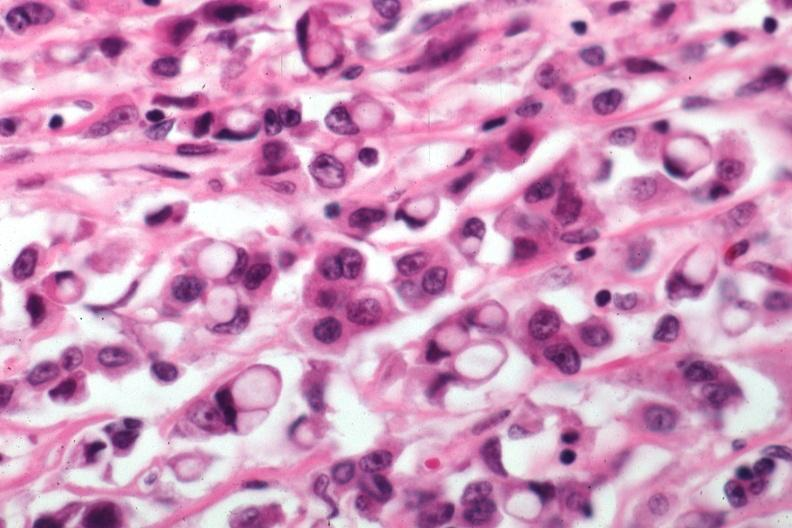does very good example show pleomorphic cells with obvious mucin secretion?
Answer the question using a single word or phrase. No 